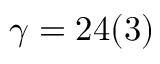Convert formula to latex. <formula><loc_0><loc_0><loc_500><loc_500>\gamma = 2 4 ( 3 )</formula> 